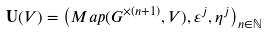<formula> <loc_0><loc_0><loc_500><loc_500>\mathbf U ( V ) = \left ( M a p ( G ^ { \times ( n + 1 ) } , V ) , \varepsilon ^ { j } , \eta ^ { j } \right ) _ { n \in \mathbb { N } }</formula> 